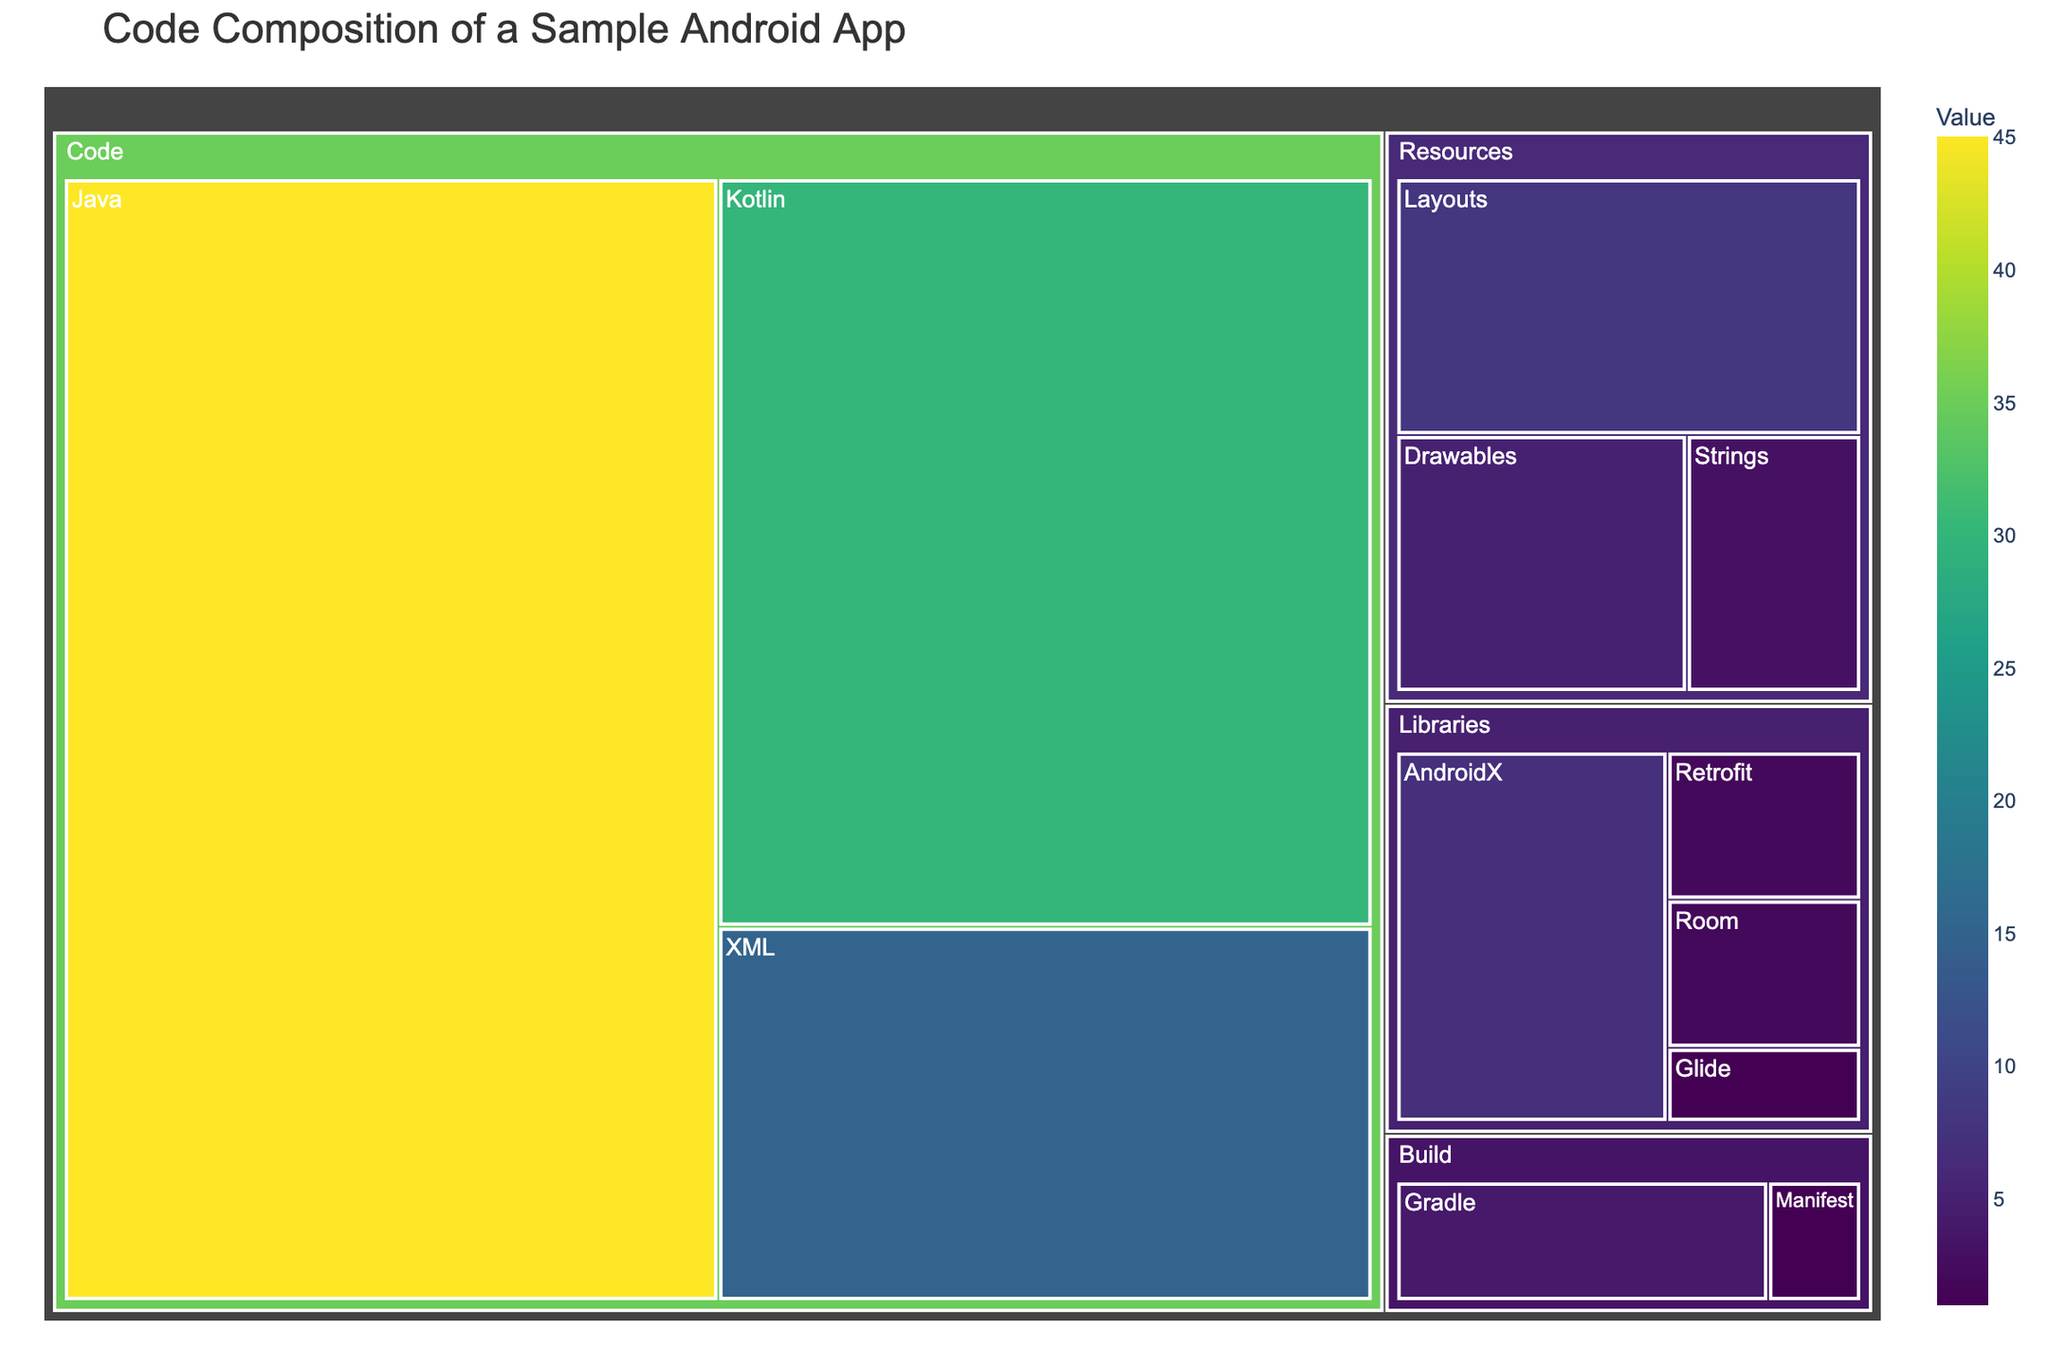What's the largest category in the treemap? By looking at the treemap, the largest section represents the category with the most value. The "Code" category occupies the largest area.
Answer: Code What's the total value of resources? The Resources section includes Drawables (5), Layouts (8), and Strings (3). Summing these up: 5 + 8 + 3 = 16.
Answer: 16 Which subcategory has the highest value within the "Code" category? In the "Code" category, the values are Java (45), Kotlin (30), and XML (15). Java has the highest value.
Answer: Java How does the value of "Kotlin" compare to that of "XML"? The value of Kotlin is 30 while XML is 15. Since 30 is greater than 15, Kotlin has a higher value than XML.
Answer: Kotlin has a higher value than XML What is the smallest value in the "Libraries" category? The "Libraries" category includes AndroidX (7), Retrofit (2), Glide (1), and Room (2). Glide has the smallest value.
Answer: Glide What is the combined value of "Java" and "Kotlin"? The value for Java is 45 and for Kotlin is 30. Summing these up: 45 + 30 = 75.
Answer: 75 Which category does the subcategory "Gradle" belong to? Gradle is a subcategory under the "Build" category.
Answer: Build Is the value of "Drawables" in the Resources category more than that of "Manifest" in the Build category? Drawables value is 5 and Manifest value is 1. Since 5 is greater than 1, Drawables has a higher value.
Answer: Yes What is the proportion of "Java" compared to the total code value? Java's value is 45, and the total code value is Java (45) + Kotlin (30) + XML (15) = 90. The proportion is 45/90 = 0.5 or 50%.
Answer: 50% What subcategory is the smallest in the entire treemap? Comparing all values, Glide has the smallest value of 1.
Answer: Glide 